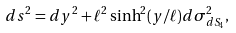Convert formula to latex. <formula><loc_0><loc_0><loc_500><loc_500>d s ^ { 2 } = d y ^ { 2 } + \ell ^ { 2 } \sinh ^ { 2 } ( y / \ell ) d \sigma _ { d S _ { 4 } } ^ { 2 } ,</formula> 